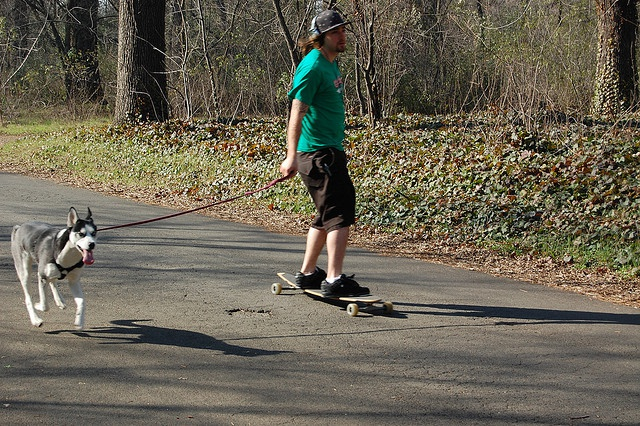Describe the objects in this image and their specific colors. I can see people in black, gray, and maroon tones, dog in black, gray, darkgray, and ivory tones, and skateboard in black, darkgray, gray, and beige tones in this image. 